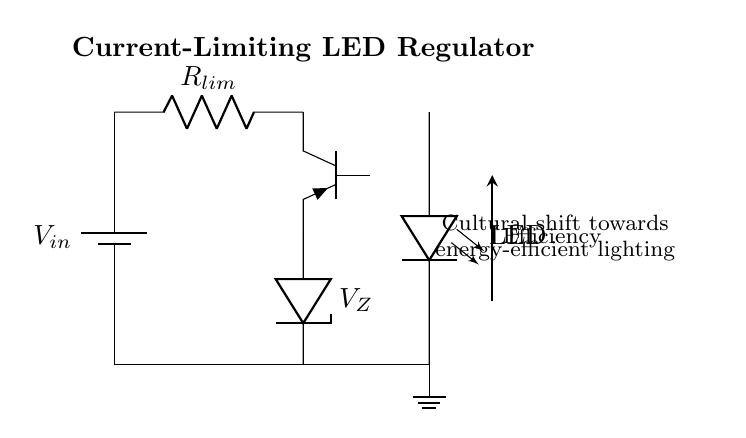What is the power supply type used in the circuit? The circuit diagram includes a battery as the power source, indicated by the symbol showing a battery with a specified voltage.
Answer: Battery What is the purpose of the current-limiting resistor in this circuit? The current-limiting resistor, labeled R lim, is used to restrict the amount of current flowing through the LED, protecting it from exceeding its maximum rating.
Answer: Protect LED What is the type of transistor used in this regulator? The diagram shows a PNP transistor, denoted by the symbol with "pnp" written beside it, which is typically used for current regulation in LED applications.
Answer: PNP How many main components are present in this circuit? By counting the individual components labeled in the circuit - battery, resistor, transistor, zener diode, and LED - the total comes to five main components.
Answer: Five What role does the zener diode play in this circuit? The zener diode, labeled V Z, functions to regulate the voltage across the load by maintaining a constant voltage level, ensuring that the LED receives a stable voltage.
Answer: Voltage regulation What is indicated by the note about a cultural shift in the diagram? The diagram includes a note that highlights the cultural shift towards energy-efficient lighting, signifying the increasing importance of sustainability and energy conservation in lighting technology.
Answer: Energy-efficient lighting What is the significance of the efficiency arrow in the circuit? The efficiency arrow emphasizes that the circuit design is intended to maximize energy efficiency, which is a key goal in modern lighting solutions to reduce energy consumption.
Answer: Maximizing efficiency 